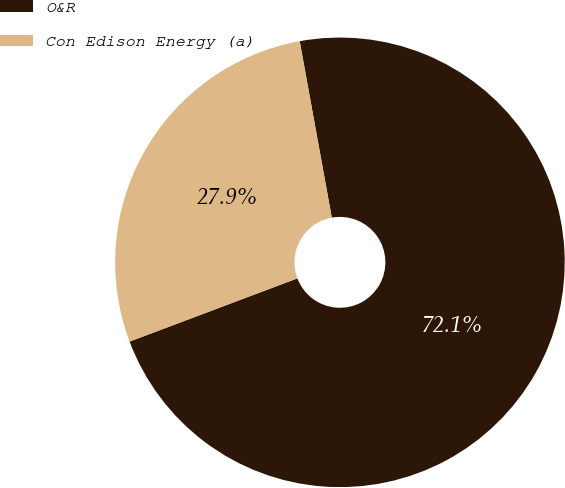<chart> <loc_0><loc_0><loc_500><loc_500><pie_chart><fcel>O&R<fcel>Con Edison Energy (a)<nl><fcel>72.13%<fcel>27.87%<nl></chart> 